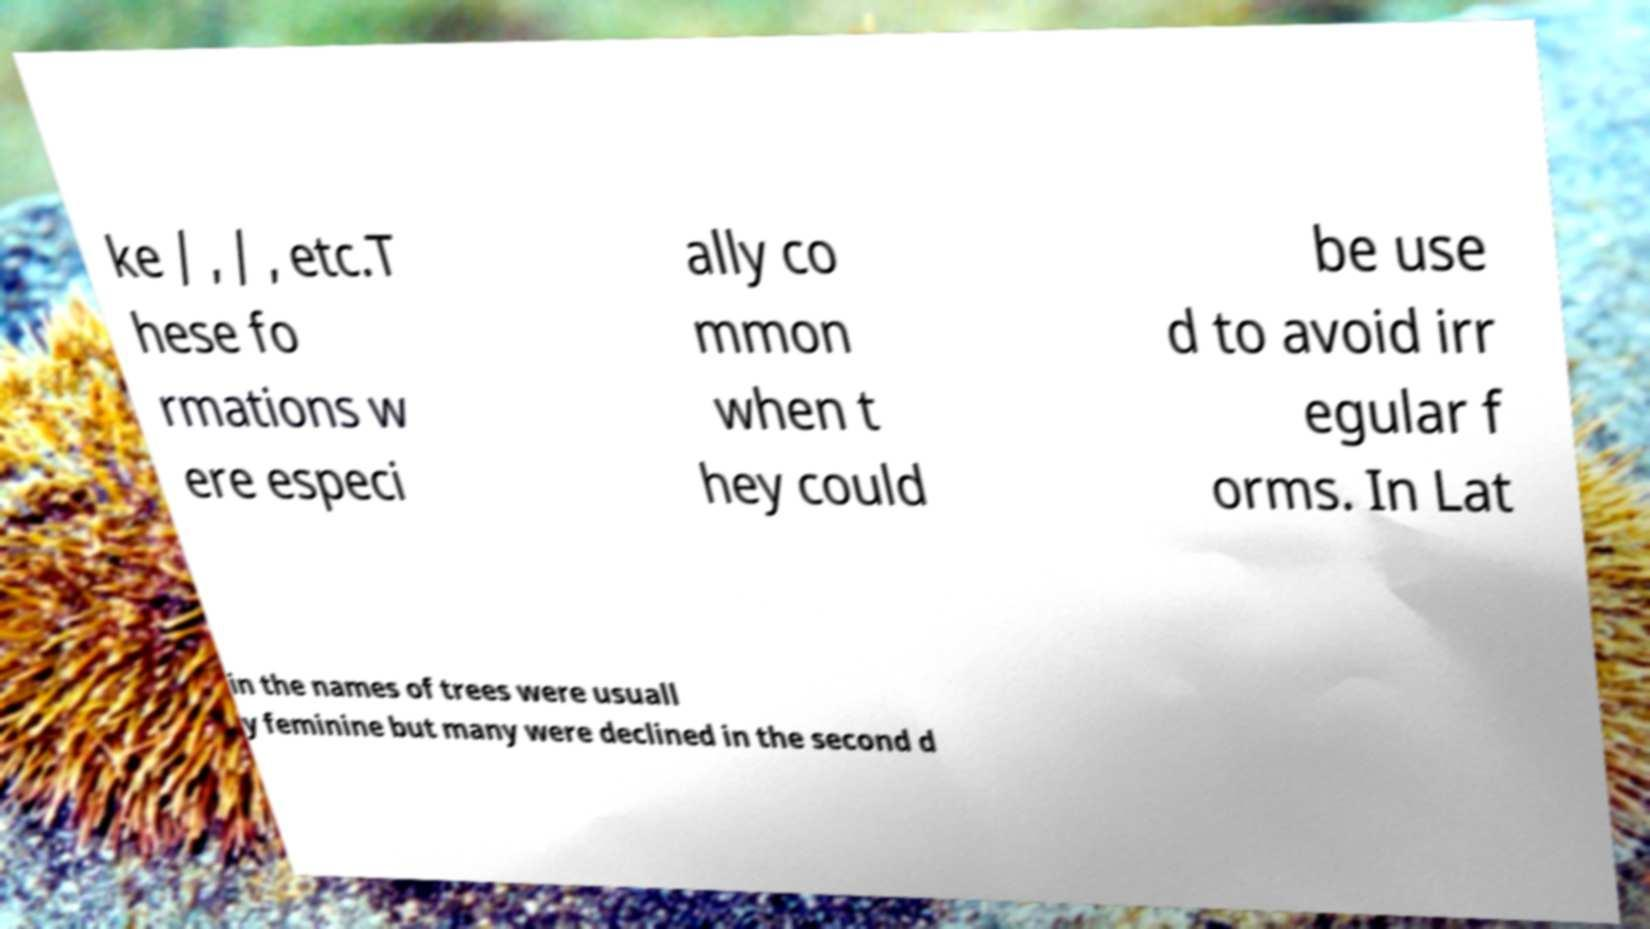What messages or text are displayed in this image? I need them in a readable, typed format. ke / , / , etc.T hese fo rmations w ere especi ally co mmon when t hey could be use d to avoid irr egular f orms. In Lat in the names of trees were usuall y feminine but many were declined in the second d 